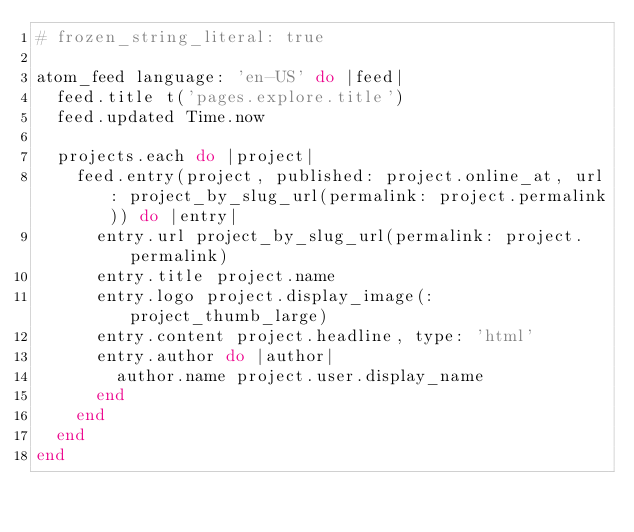<code> <loc_0><loc_0><loc_500><loc_500><_Ruby_># frozen_string_literal: true

atom_feed language: 'en-US' do |feed|
  feed.title t('pages.explore.title')
  feed.updated Time.now

  projects.each do |project|
    feed.entry(project, published: project.online_at, url: project_by_slug_url(permalink: project.permalink)) do |entry|
      entry.url project_by_slug_url(permalink: project.permalink)
      entry.title project.name
      entry.logo project.display_image(:project_thumb_large)
      entry.content project.headline, type: 'html'
      entry.author do |author|
        author.name project.user.display_name
      end
    end
  end
end
</code> 